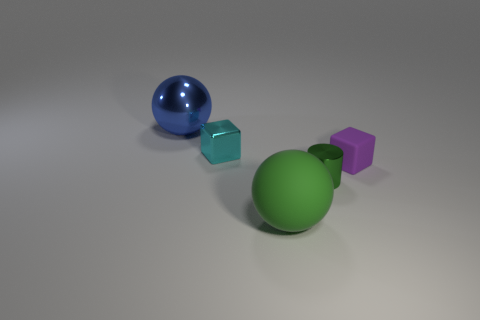What is the material of the ball that is the same color as the small cylinder?
Offer a terse response. Rubber. Is there a large rubber sphere that has the same color as the small cylinder?
Your response must be concise. Yes. Does the small purple object have the same shape as the thing in front of the small green metal thing?
Ensure brevity in your answer.  No. Is there a tiny cylinder made of the same material as the blue ball?
Provide a succinct answer. Yes. Is there a green metal cylinder behind the tiny block that is to the left of the small cube that is on the right side of the cyan metallic thing?
Give a very brief answer. No. What number of other objects are there of the same shape as the small cyan object?
Provide a succinct answer. 1. There is a rubber object that is behind the small metallic thing that is to the right of the big sphere that is in front of the tiny green thing; what is its color?
Provide a succinct answer. Purple. What number of big green balls are there?
Your answer should be compact. 1. How many tiny objects are either cyan shiny cubes or green matte balls?
Provide a succinct answer. 1. There is a blue thing that is the same size as the green matte thing; what shape is it?
Your answer should be very brief. Sphere. 